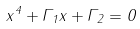<formula> <loc_0><loc_0><loc_500><loc_500>x ^ { 4 } + \Gamma _ { 1 } x + \Gamma _ { 2 } = 0</formula> 